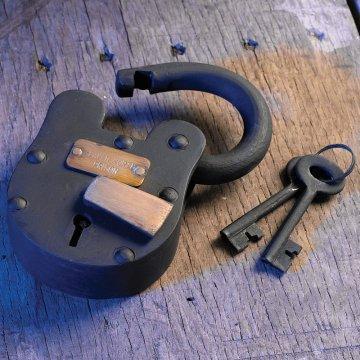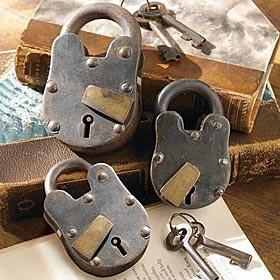The first image is the image on the left, the second image is the image on the right. Given the left and right images, does the statement "Each image contains only non-square vintage locks and contains at least one key." hold true? Answer yes or no. Yes. The first image is the image on the left, the second image is the image on the right. Considering the images on both sides, is "At least one key is lying beside a lock." valid? Answer yes or no. Yes. 